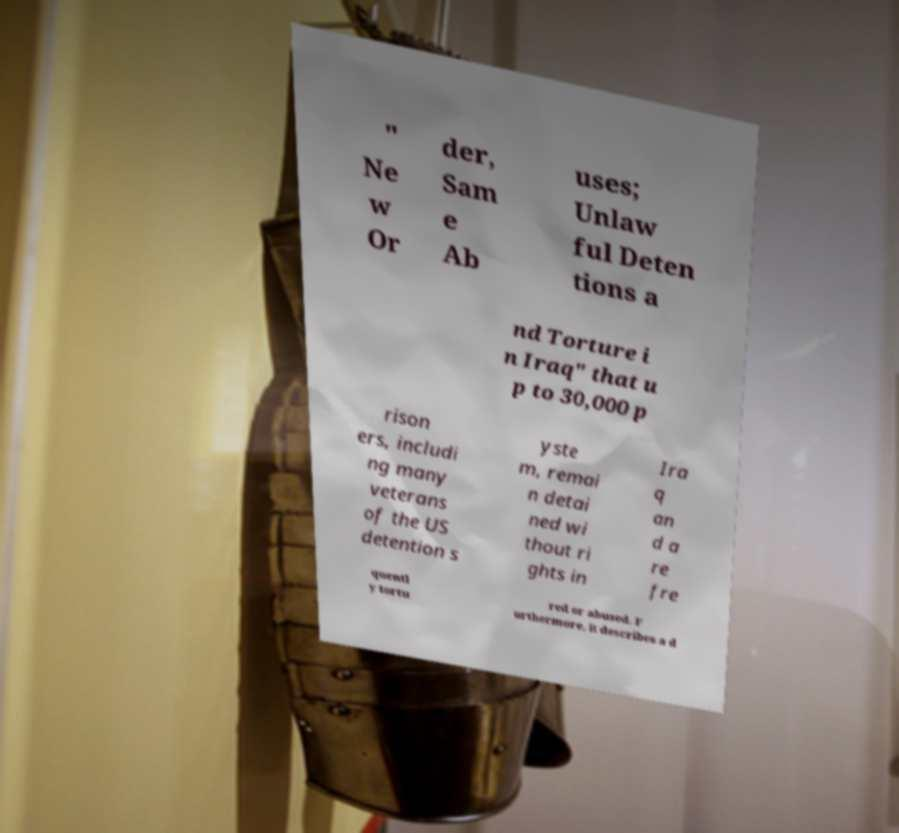There's text embedded in this image that I need extracted. Can you transcribe it verbatim? " Ne w Or der, Sam e Ab uses; Unlaw ful Deten tions a nd Torture i n Iraq" that u p to 30,000 p rison ers, includi ng many veterans of the US detention s yste m, remai n detai ned wi thout ri ghts in Ira q an d a re fre quentl y tortu red or abused. F urthermore, it describes a d 